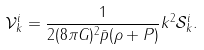<formula> <loc_0><loc_0><loc_500><loc_500>\mathcal { V } _ { k } ^ { i } = \frac { 1 } { 2 ( 8 \pi G ) ^ { 2 } \bar { p } ( \rho + P ) } k ^ { 2 } \mathcal { S } _ { k } ^ { i } .</formula> 